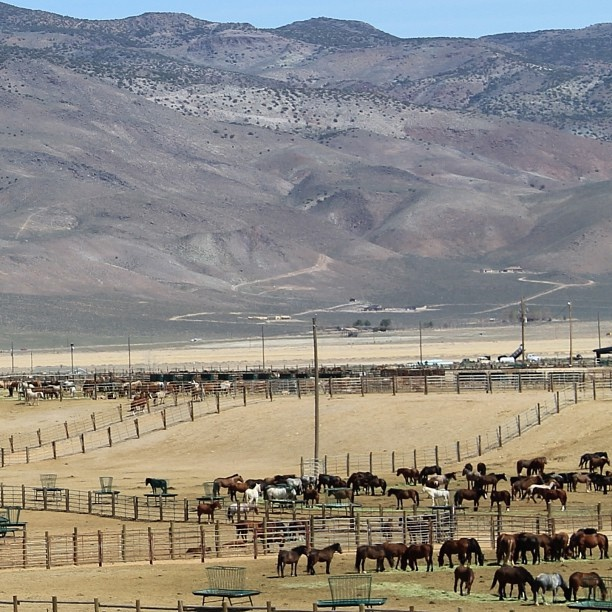Describe the objects in this image and their specific colors. I can see horse in lightblue, darkgray, tan, and gray tones, bench in lightblue, olive, gray, and darkgreen tones, horse in lightblue, black, and gray tones, horse in lightblue, black, maroon, and gray tones, and horse in lightblue, black, maroon, and gray tones in this image. 